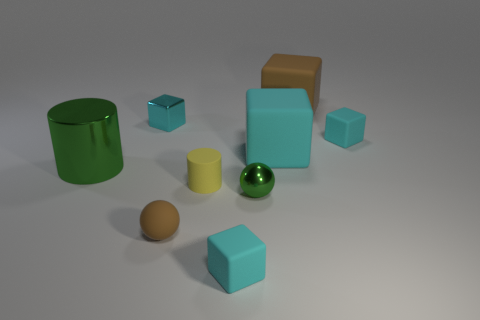Subtract all green balls. How many cyan blocks are left? 4 Subtract 1 blocks. How many blocks are left? 4 Subtract all brown cubes. How many cubes are left? 4 Subtract all metallic blocks. How many blocks are left? 4 Subtract all red blocks. Subtract all purple spheres. How many blocks are left? 5 Subtract all cubes. How many objects are left? 4 Add 7 big brown things. How many big brown things exist? 8 Subtract 0 red cylinders. How many objects are left? 9 Subtract all cyan shiny cubes. Subtract all small cyan metallic cubes. How many objects are left? 7 Add 5 tiny cyan matte objects. How many tiny cyan matte objects are left? 7 